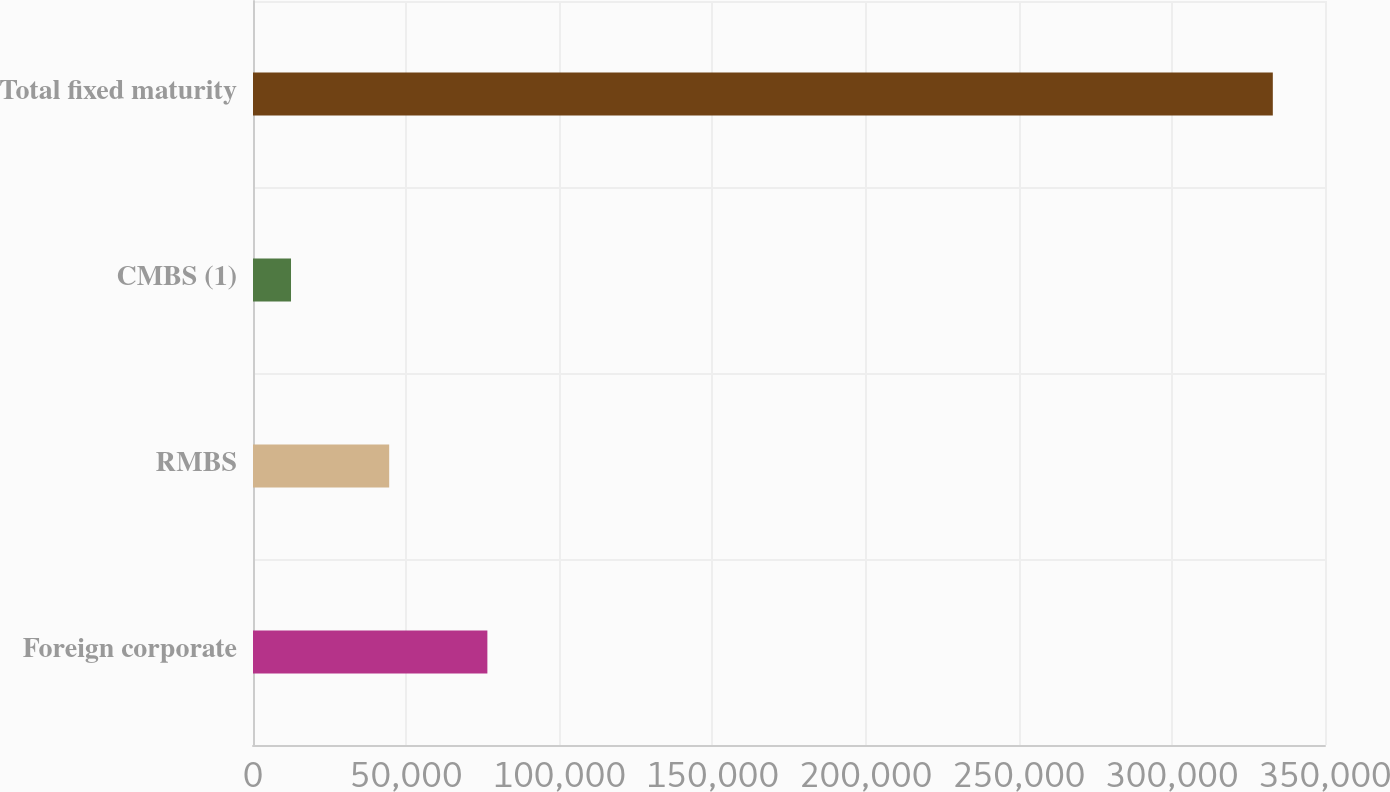Convert chart. <chart><loc_0><loc_0><loc_500><loc_500><bar_chart><fcel>Foreign corporate<fcel>RMBS<fcel>CMBS (1)<fcel>Total fixed maturity<nl><fcel>76520.8<fcel>44465.4<fcel>12410<fcel>332964<nl></chart> 